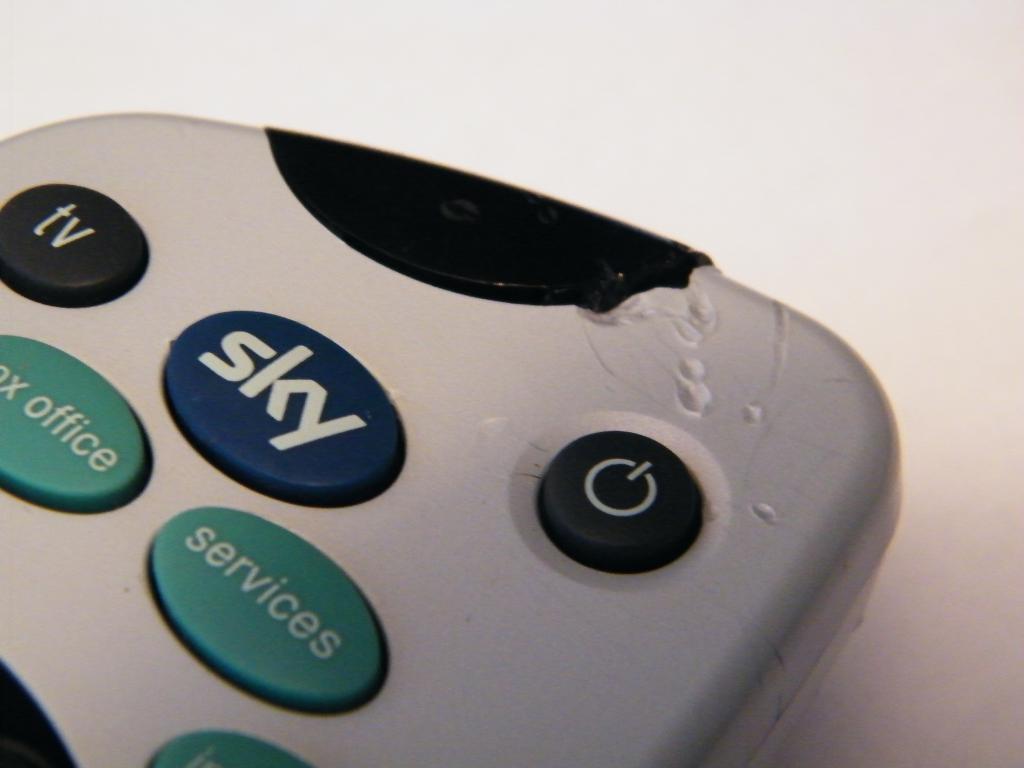What is written on top blue button?
Provide a succinct answer. Sky. 